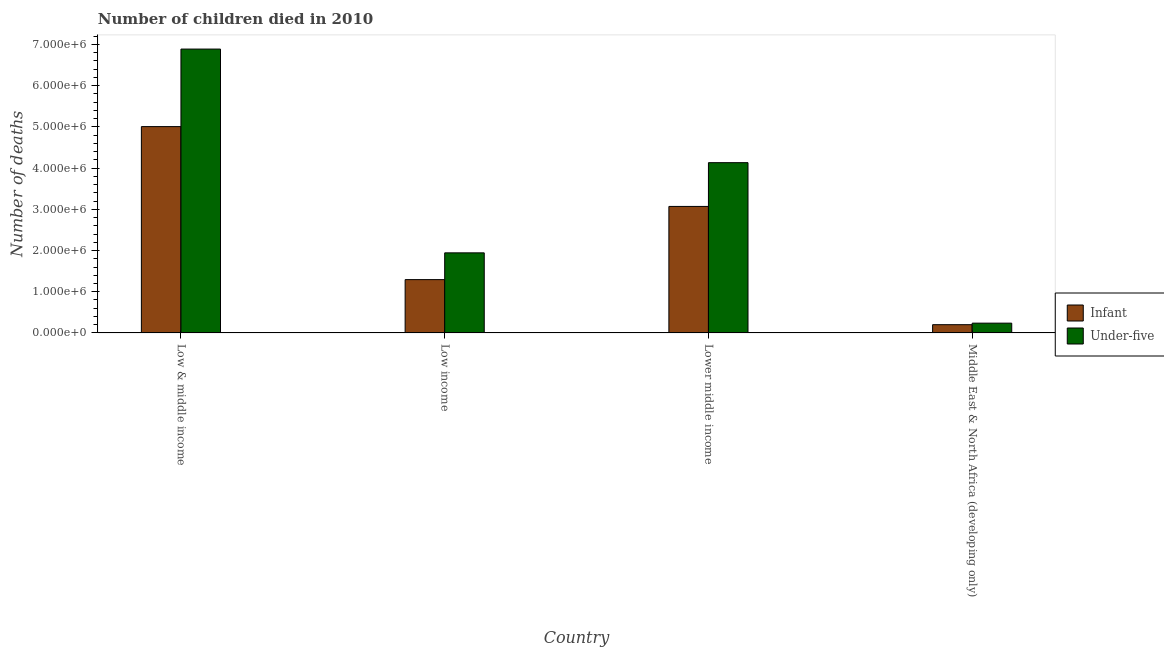How many different coloured bars are there?
Offer a very short reply. 2. Are the number of bars per tick equal to the number of legend labels?
Provide a short and direct response. Yes. How many bars are there on the 2nd tick from the left?
Your response must be concise. 2. How many bars are there on the 1st tick from the right?
Provide a succinct answer. 2. What is the label of the 4th group of bars from the left?
Make the answer very short. Middle East & North Africa (developing only). What is the number of infant deaths in Low income?
Provide a succinct answer. 1.29e+06. Across all countries, what is the maximum number of under-five deaths?
Your response must be concise. 6.89e+06. Across all countries, what is the minimum number of infant deaths?
Provide a short and direct response. 2.00e+05. In which country was the number of under-five deaths maximum?
Provide a short and direct response. Low & middle income. In which country was the number of infant deaths minimum?
Offer a terse response. Middle East & North Africa (developing only). What is the total number of under-five deaths in the graph?
Your answer should be compact. 1.32e+07. What is the difference between the number of infant deaths in Low income and that in Lower middle income?
Your answer should be very brief. -1.78e+06. What is the difference between the number of infant deaths in Lower middle income and the number of under-five deaths in Low & middle income?
Keep it short and to the point. -3.82e+06. What is the average number of under-five deaths per country?
Ensure brevity in your answer.  3.30e+06. What is the difference between the number of infant deaths and number of under-five deaths in Middle East & North Africa (developing only)?
Make the answer very short. -3.74e+04. What is the ratio of the number of infant deaths in Low income to that in Middle East & North Africa (developing only)?
Provide a short and direct response. 6.46. Is the difference between the number of infant deaths in Low & middle income and Lower middle income greater than the difference between the number of under-five deaths in Low & middle income and Lower middle income?
Your response must be concise. No. What is the difference between the highest and the second highest number of infant deaths?
Offer a terse response. 1.94e+06. What is the difference between the highest and the lowest number of infant deaths?
Offer a very short reply. 4.81e+06. In how many countries, is the number of infant deaths greater than the average number of infant deaths taken over all countries?
Keep it short and to the point. 2. What does the 2nd bar from the left in Low income represents?
Make the answer very short. Under-five. What does the 1st bar from the right in Low & middle income represents?
Provide a succinct answer. Under-five. How many bars are there?
Provide a succinct answer. 8. Does the graph contain grids?
Your answer should be compact. No. Where does the legend appear in the graph?
Offer a very short reply. Center right. How many legend labels are there?
Ensure brevity in your answer.  2. How are the legend labels stacked?
Your answer should be very brief. Vertical. What is the title of the graph?
Provide a short and direct response. Number of children died in 2010. What is the label or title of the Y-axis?
Offer a terse response. Number of deaths. What is the Number of deaths of Infant in Low & middle income?
Give a very brief answer. 5.01e+06. What is the Number of deaths of Under-five in Low & middle income?
Offer a very short reply. 6.89e+06. What is the Number of deaths in Infant in Low income?
Keep it short and to the point. 1.29e+06. What is the Number of deaths in Under-five in Low income?
Ensure brevity in your answer.  1.94e+06. What is the Number of deaths of Infant in Lower middle income?
Offer a terse response. 3.07e+06. What is the Number of deaths in Under-five in Lower middle income?
Your answer should be compact. 4.13e+06. What is the Number of deaths in Infant in Middle East & North Africa (developing only)?
Offer a terse response. 2.00e+05. What is the Number of deaths of Under-five in Middle East & North Africa (developing only)?
Provide a short and direct response. 2.38e+05. Across all countries, what is the maximum Number of deaths in Infant?
Provide a succinct answer. 5.01e+06. Across all countries, what is the maximum Number of deaths in Under-five?
Give a very brief answer. 6.89e+06. Across all countries, what is the minimum Number of deaths in Infant?
Offer a very short reply. 2.00e+05. Across all countries, what is the minimum Number of deaths in Under-five?
Your answer should be compact. 2.38e+05. What is the total Number of deaths of Infant in the graph?
Provide a succinct answer. 9.57e+06. What is the total Number of deaths of Under-five in the graph?
Ensure brevity in your answer.  1.32e+07. What is the difference between the Number of deaths in Infant in Low & middle income and that in Low income?
Provide a succinct answer. 3.71e+06. What is the difference between the Number of deaths in Under-five in Low & middle income and that in Low income?
Your response must be concise. 4.94e+06. What is the difference between the Number of deaths of Infant in Low & middle income and that in Lower middle income?
Give a very brief answer. 1.94e+06. What is the difference between the Number of deaths in Under-five in Low & middle income and that in Lower middle income?
Give a very brief answer. 2.76e+06. What is the difference between the Number of deaths of Infant in Low & middle income and that in Middle East & North Africa (developing only)?
Provide a succinct answer. 4.81e+06. What is the difference between the Number of deaths of Under-five in Low & middle income and that in Middle East & North Africa (developing only)?
Make the answer very short. 6.65e+06. What is the difference between the Number of deaths in Infant in Low income and that in Lower middle income?
Offer a terse response. -1.78e+06. What is the difference between the Number of deaths of Under-five in Low income and that in Lower middle income?
Ensure brevity in your answer.  -2.19e+06. What is the difference between the Number of deaths of Infant in Low income and that in Middle East & North Africa (developing only)?
Keep it short and to the point. 1.09e+06. What is the difference between the Number of deaths in Under-five in Low income and that in Middle East & North Africa (developing only)?
Provide a succinct answer. 1.71e+06. What is the difference between the Number of deaths in Infant in Lower middle income and that in Middle East & North Africa (developing only)?
Ensure brevity in your answer.  2.87e+06. What is the difference between the Number of deaths of Under-five in Lower middle income and that in Middle East & North Africa (developing only)?
Provide a short and direct response. 3.89e+06. What is the difference between the Number of deaths in Infant in Low & middle income and the Number of deaths in Under-five in Low income?
Provide a short and direct response. 3.06e+06. What is the difference between the Number of deaths in Infant in Low & middle income and the Number of deaths in Under-five in Lower middle income?
Provide a succinct answer. 8.75e+05. What is the difference between the Number of deaths in Infant in Low & middle income and the Number of deaths in Under-five in Middle East & North Africa (developing only)?
Offer a terse response. 4.77e+06. What is the difference between the Number of deaths in Infant in Low income and the Number of deaths in Under-five in Lower middle income?
Provide a short and direct response. -2.84e+06. What is the difference between the Number of deaths in Infant in Low income and the Number of deaths in Under-five in Middle East & North Africa (developing only)?
Provide a short and direct response. 1.06e+06. What is the difference between the Number of deaths of Infant in Lower middle income and the Number of deaths of Under-five in Middle East & North Africa (developing only)?
Offer a terse response. 2.83e+06. What is the average Number of deaths of Infant per country?
Provide a short and direct response. 2.39e+06. What is the average Number of deaths of Under-five per country?
Your answer should be very brief. 3.30e+06. What is the difference between the Number of deaths of Infant and Number of deaths of Under-five in Low & middle income?
Keep it short and to the point. -1.88e+06. What is the difference between the Number of deaths of Infant and Number of deaths of Under-five in Low income?
Your response must be concise. -6.50e+05. What is the difference between the Number of deaths of Infant and Number of deaths of Under-five in Lower middle income?
Make the answer very short. -1.06e+06. What is the difference between the Number of deaths in Infant and Number of deaths in Under-five in Middle East & North Africa (developing only)?
Your answer should be very brief. -3.74e+04. What is the ratio of the Number of deaths in Infant in Low & middle income to that in Low income?
Offer a terse response. 3.87. What is the ratio of the Number of deaths in Under-five in Low & middle income to that in Low income?
Offer a terse response. 3.54. What is the ratio of the Number of deaths in Infant in Low & middle income to that in Lower middle income?
Provide a short and direct response. 1.63. What is the ratio of the Number of deaths in Under-five in Low & middle income to that in Lower middle income?
Your response must be concise. 1.67. What is the ratio of the Number of deaths in Infant in Low & middle income to that in Middle East & North Africa (developing only)?
Give a very brief answer. 24.98. What is the ratio of the Number of deaths in Under-five in Low & middle income to that in Middle East & North Africa (developing only)?
Your answer should be very brief. 28.97. What is the ratio of the Number of deaths of Infant in Low income to that in Lower middle income?
Make the answer very short. 0.42. What is the ratio of the Number of deaths in Under-five in Low income to that in Lower middle income?
Your response must be concise. 0.47. What is the ratio of the Number of deaths of Infant in Low income to that in Middle East & North Africa (developing only)?
Ensure brevity in your answer.  6.46. What is the ratio of the Number of deaths of Under-five in Low income to that in Middle East & North Africa (developing only)?
Make the answer very short. 8.17. What is the ratio of the Number of deaths in Infant in Lower middle income to that in Middle East & North Africa (developing only)?
Make the answer very short. 15.32. What is the ratio of the Number of deaths of Under-five in Lower middle income to that in Middle East & North Africa (developing only)?
Make the answer very short. 17.38. What is the difference between the highest and the second highest Number of deaths of Infant?
Provide a succinct answer. 1.94e+06. What is the difference between the highest and the second highest Number of deaths in Under-five?
Make the answer very short. 2.76e+06. What is the difference between the highest and the lowest Number of deaths in Infant?
Offer a terse response. 4.81e+06. What is the difference between the highest and the lowest Number of deaths in Under-five?
Make the answer very short. 6.65e+06. 